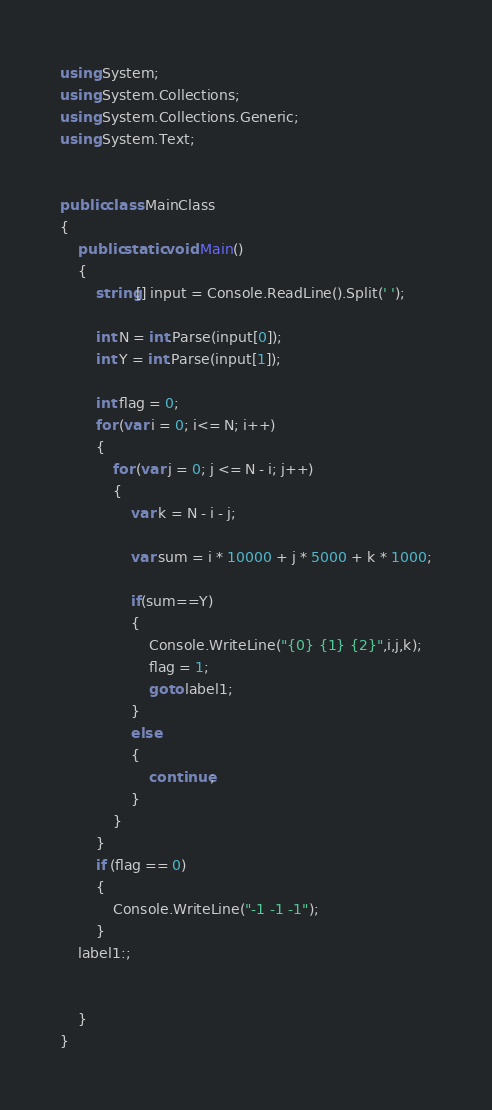<code> <loc_0><loc_0><loc_500><loc_500><_C#_>using System;
using System.Collections;
using System.Collections.Generic;
using System.Text;


public class MainClass
{
	public static void Main()
	{
		string[] input = Console.ReadLine().Split(' ');

		int N = int.Parse(input[0]);
		int Y = int.Parse(input[1]);

		int flag = 0;
		for (var i = 0; i<= N; i++)
		{
			for (var j = 0; j <= N - i; j++)
			{
				var k = N - i - j;

				var sum = i * 10000 + j * 5000 + k * 1000;

				if(sum==Y)
				{
					Console.WriteLine("{0} {1} {2}",i,j,k);
					flag = 1;
					goto label1;
				}
				else
				{
					continue;
				}
			}
		}
		if (flag == 0)
		{
			Console.WriteLine("-1 -1 -1");
		}
	label1:;


	}
}



</code> 